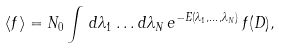Convert formula to latex. <formula><loc_0><loc_0><loc_500><loc_500>\langle f \rangle = N _ { 0 } \int \, d \lambda _ { 1 } \dots d \lambda _ { N } \, e ^ { - E ( \lambda _ { 1 } , \dots , \lambda _ { N } ) } \, f ( D ) ,</formula> 